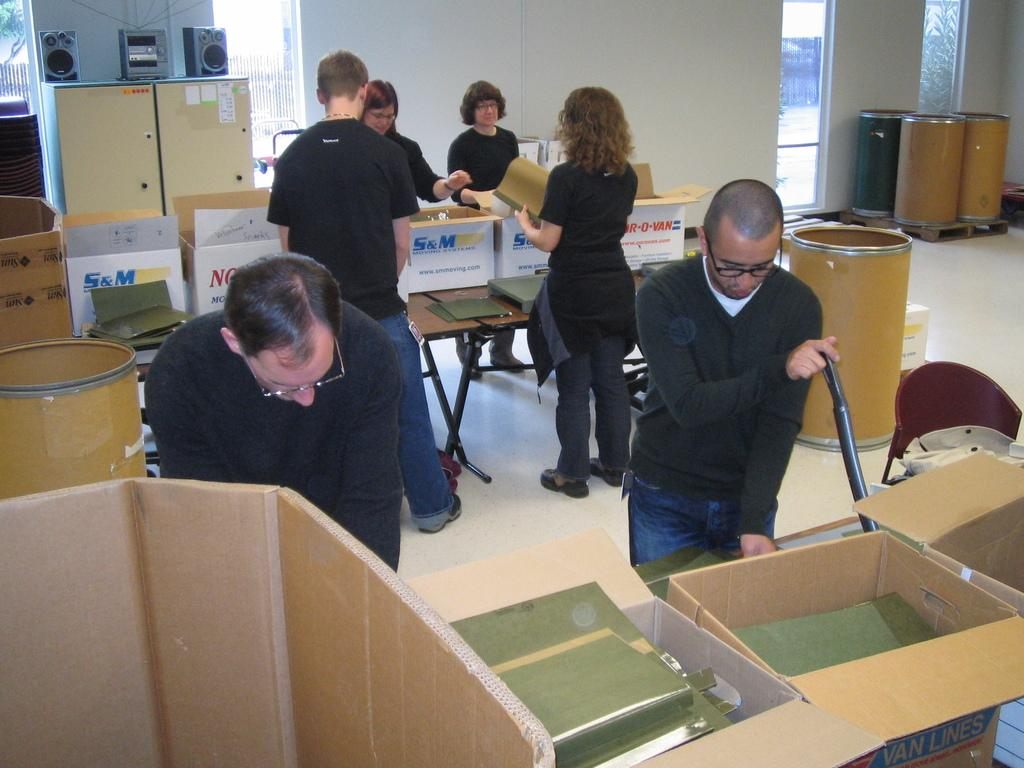What are the people in the image doing? The people in the image are standing on the floor and holding objects in their hands. What type of objects are the people holding? The objects held by the people are not specified, but they are holding something. What can be seen in the image besides the people? There are boxes, drums, a music system, sound speakers, a wall, and other unspecified objects in the image. What does the caption say about the people in the image? There is no caption present in the image, so it is not possible to answer that question. 